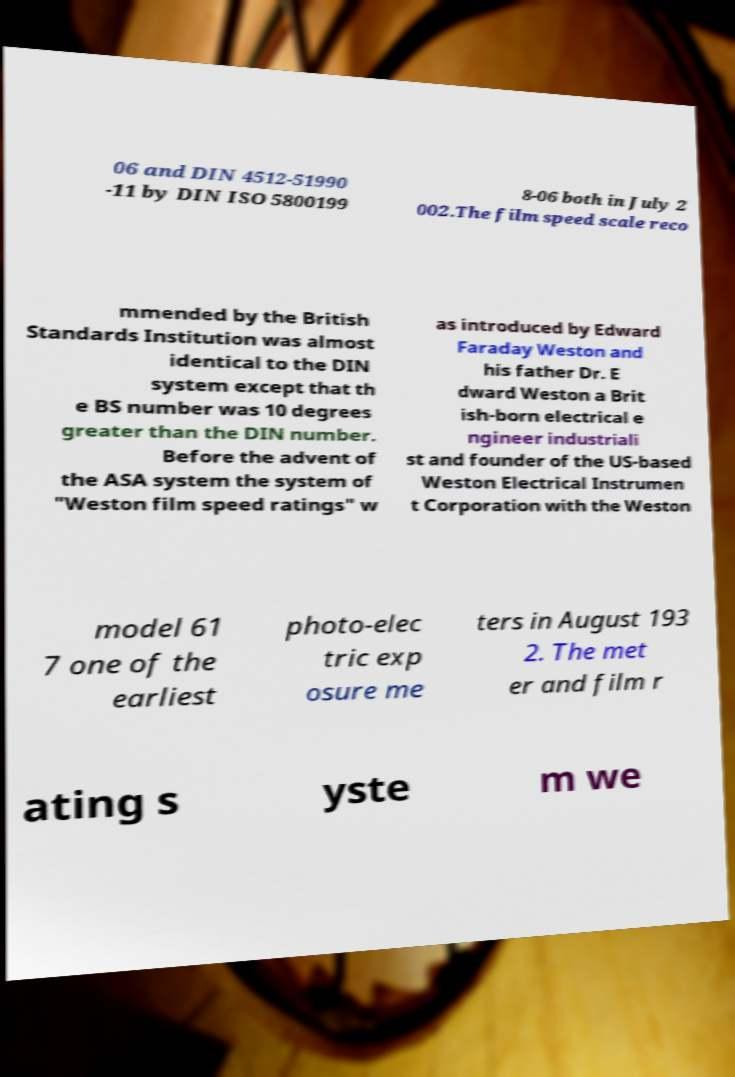For documentation purposes, I need the text within this image transcribed. Could you provide that? 06 and DIN 4512-51990 -11 by DIN ISO 5800199 8-06 both in July 2 002.The film speed scale reco mmended by the British Standards Institution was almost identical to the DIN system except that th e BS number was 10 degrees greater than the DIN number. Before the advent of the ASA system the system of "Weston film speed ratings" w as introduced by Edward Faraday Weston and his father Dr. E dward Weston a Brit ish-born electrical e ngineer industriali st and founder of the US-based Weston Electrical Instrumen t Corporation with the Weston model 61 7 one of the earliest photo-elec tric exp osure me ters in August 193 2. The met er and film r ating s yste m we 